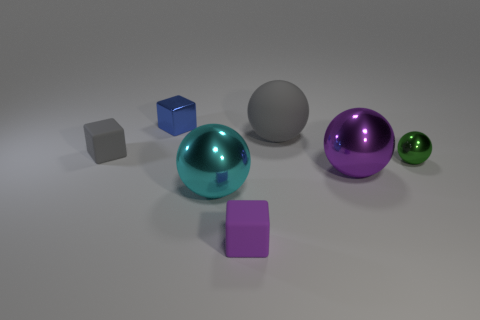Subtract all rubber cubes. How many cubes are left? 1 Subtract all green balls. How many balls are left? 3 Subtract 1 cubes. How many cubes are left? 2 Add 3 cyan cylinders. How many objects exist? 10 Subtract all red spheres. Subtract all cyan cubes. How many spheres are left? 4 Subtract all cubes. How many objects are left? 4 Add 6 large gray matte spheres. How many large gray matte spheres exist? 7 Subtract 1 purple spheres. How many objects are left? 6 Subtract all metal cubes. Subtract all balls. How many objects are left? 2 Add 5 rubber objects. How many rubber objects are left? 8 